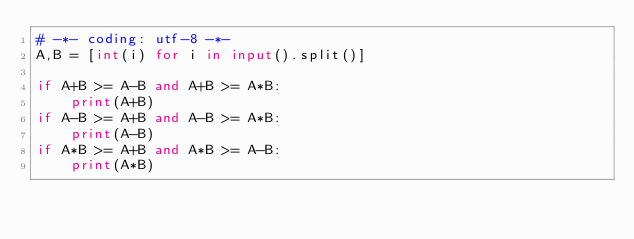<code> <loc_0><loc_0><loc_500><loc_500><_Python_># -*- coding: utf-8 -*-
A,B = [int(i) for i in input().split()]

if A+B >= A-B and A+B >= A*B:
    print(A+B)
if A-B >= A+B and A-B >= A*B:
    print(A-B)
if A*B >= A+B and A*B >= A-B:
    print(A*B)
</code> 